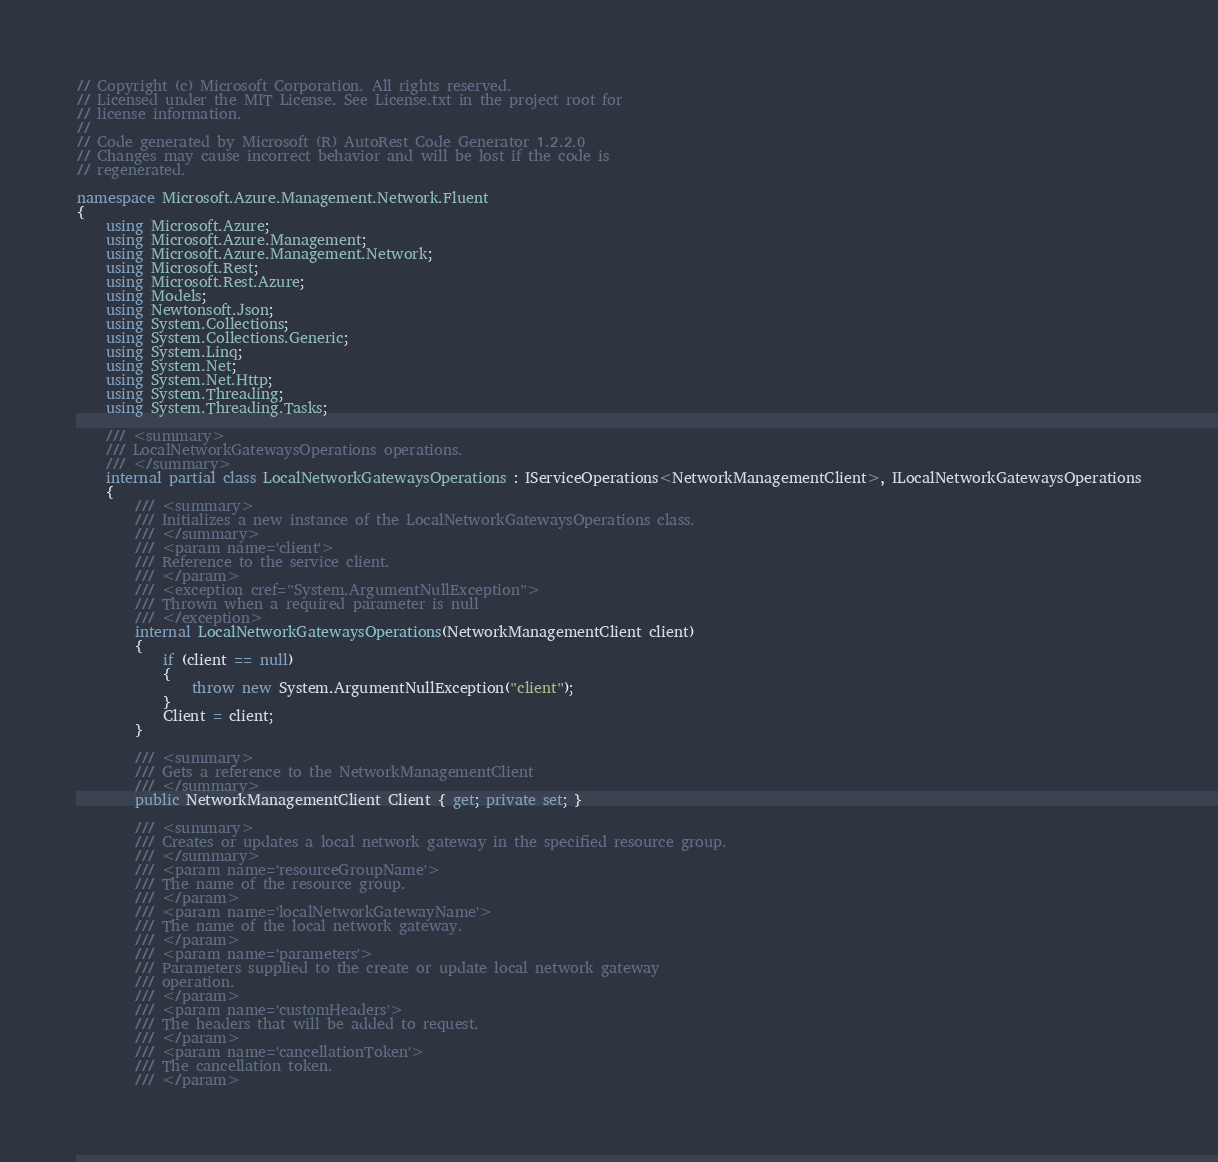Convert code to text. <code><loc_0><loc_0><loc_500><loc_500><_C#_>// Copyright (c) Microsoft Corporation. All rights reserved.
// Licensed under the MIT License. See License.txt in the project root for
// license information.
//
// Code generated by Microsoft (R) AutoRest Code Generator 1.2.2.0
// Changes may cause incorrect behavior and will be lost if the code is
// regenerated.

namespace Microsoft.Azure.Management.Network.Fluent
{
    using Microsoft.Azure;
    using Microsoft.Azure.Management;
    using Microsoft.Azure.Management.Network;
    using Microsoft.Rest;
    using Microsoft.Rest.Azure;
    using Models;
    using Newtonsoft.Json;
    using System.Collections;
    using System.Collections.Generic;
    using System.Linq;
    using System.Net;
    using System.Net.Http;
    using System.Threading;
    using System.Threading.Tasks;

    /// <summary>
    /// LocalNetworkGatewaysOperations operations.
    /// </summary>
    internal partial class LocalNetworkGatewaysOperations : IServiceOperations<NetworkManagementClient>, ILocalNetworkGatewaysOperations
    {
        /// <summary>
        /// Initializes a new instance of the LocalNetworkGatewaysOperations class.
        /// </summary>
        /// <param name='client'>
        /// Reference to the service client.
        /// </param>
        /// <exception cref="System.ArgumentNullException">
        /// Thrown when a required parameter is null
        /// </exception>
        internal LocalNetworkGatewaysOperations(NetworkManagementClient client)
        {
            if (client == null)
            {
                throw new System.ArgumentNullException("client");
            }
            Client = client;
        }

        /// <summary>
        /// Gets a reference to the NetworkManagementClient
        /// </summary>
        public NetworkManagementClient Client { get; private set; }

        /// <summary>
        /// Creates or updates a local network gateway in the specified resource group.
        /// </summary>
        /// <param name='resourceGroupName'>
        /// The name of the resource group.
        /// </param>
        /// <param name='localNetworkGatewayName'>
        /// The name of the local network gateway.
        /// </param>
        /// <param name='parameters'>
        /// Parameters supplied to the create or update local network gateway
        /// operation.
        /// </param>
        /// <param name='customHeaders'>
        /// The headers that will be added to request.
        /// </param>
        /// <param name='cancellationToken'>
        /// The cancellation token.
        /// </param></code> 